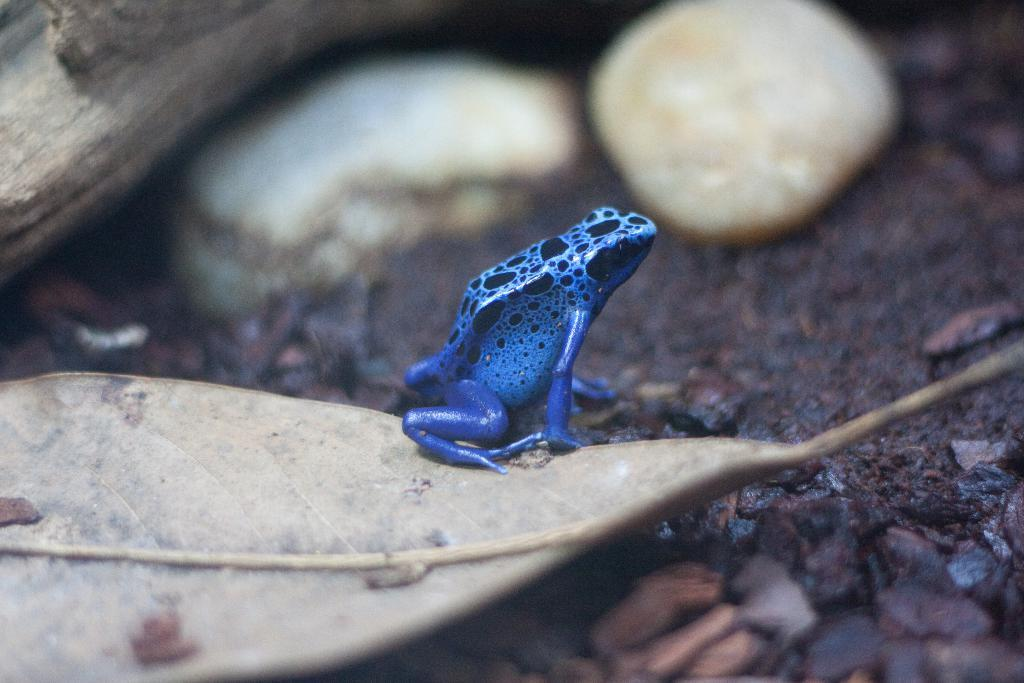What is the main subject of the image? The main subject of the image is a frog on a leaf. What other object can be seen in the image? There is a wooden stick in the image. How would you describe the background of the image? The background of the image is blurred. What type of teaching method is being demonstrated in the image? There is no teaching method or activity present in the image; it features a frog on a leaf and a wooden stick. On which side of the image is the frog located? The frog's position on the leaf cannot be determined as the image only shows the frog on a leaf, without specifying a particular side. 